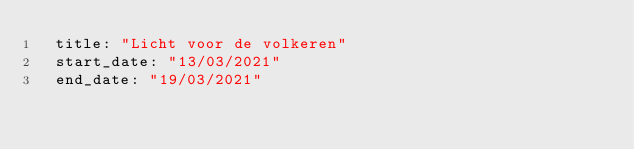<code> <loc_0><loc_0><loc_500><loc_500><_YAML_>  title: "Licht voor de volkeren"
  start_date: "13/03/2021"
  end_date: "19/03/2021"
</code> 